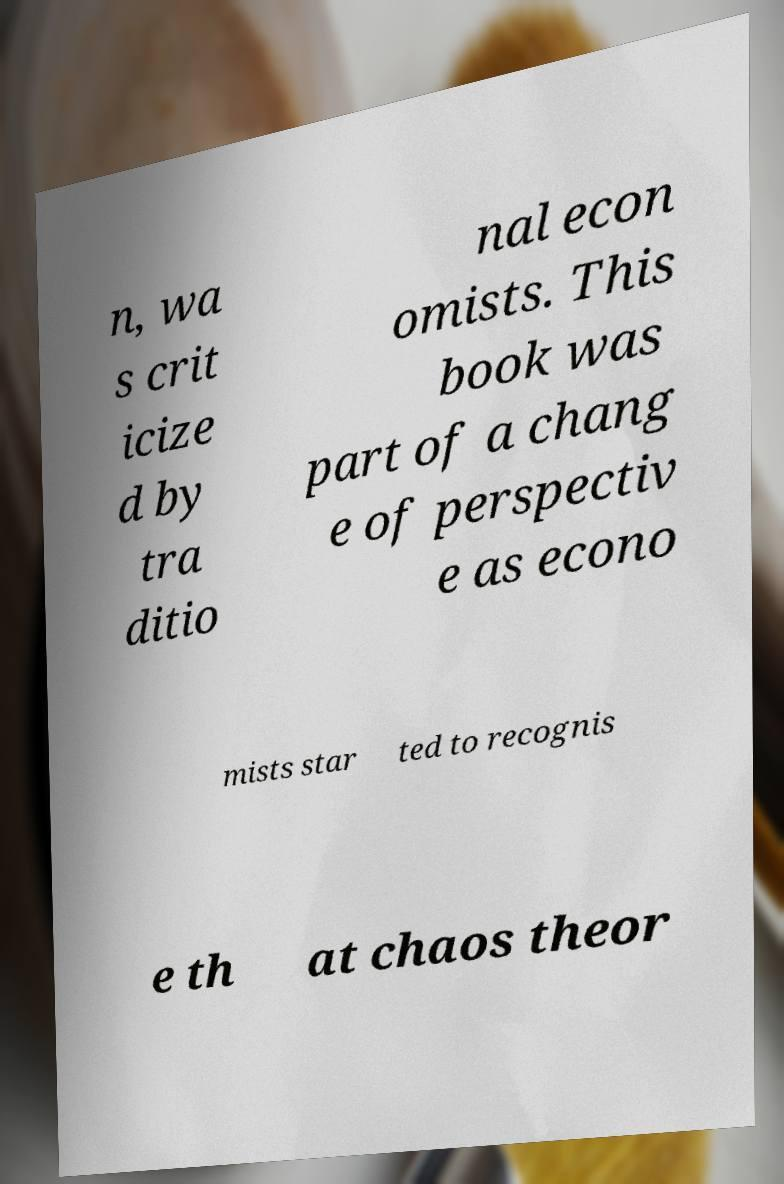For documentation purposes, I need the text within this image transcribed. Could you provide that? n, wa s crit icize d by tra ditio nal econ omists. This book was part of a chang e of perspectiv e as econo mists star ted to recognis e th at chaos theor 